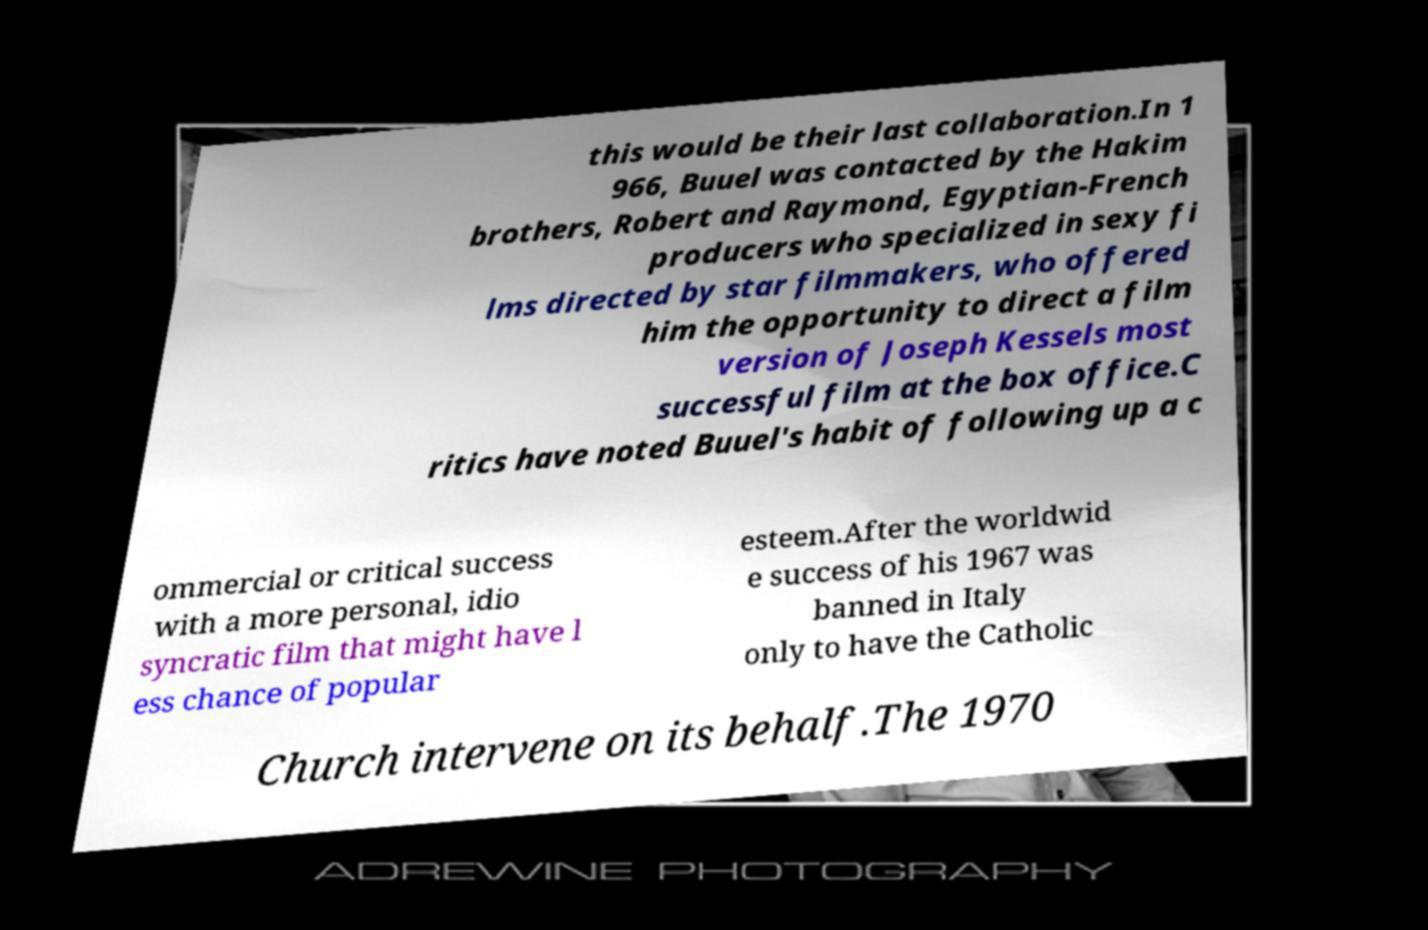For documentation purposes, I need the text within this image transcribed. Could you provide that? this would be their last collaboration.In 1 966, Buuel was contacted by the Hakim brothers, Robert and Raymond, Egyptian-French producers who specialized in sexy fi lms directed by star filmmakers, who offered him the opportunity to direct a film version of Joseph Kessels most successful film at the box office.C ritics have noted Buuel's habit of following up a c ommercial or critical success with a more personal, idio syncratic film that might have l ess chance of popular esteem.After the worldwid e success of his 1967 was banned in Italy only to have the Catholic Church intervene on its behalf.The 1970 